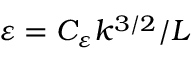<formula> <loc_0><loc_0><loc_500><loc_500>\varepsilon = C _ { \varepsilon } k ^ { 3 / 2 } / L</formula> 